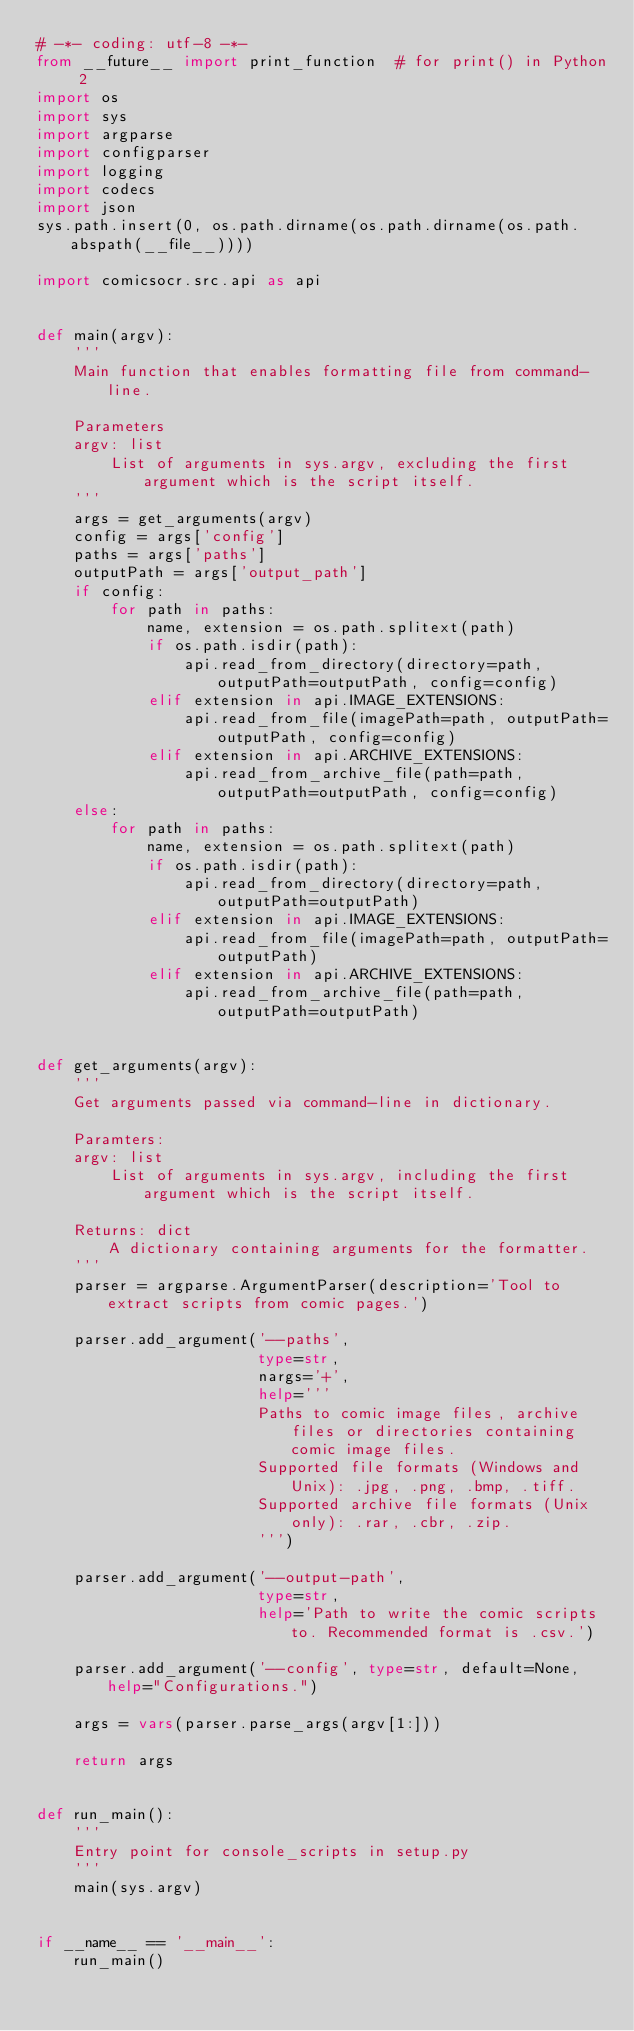<code> <loc_0><loc_0><loc_500><loc_500><_Python_># -*- coding: utf-8 -*-
from __future__ import print_function  # for print() in Python 2
import os
import sys
import argparse
import configparser
import logging
import codecs
import json
sys.path.insert(0, os.path.dirname(os.path.dirname(os.path.abspath(__file__))))

import comicsocr.src.api as api


def main(argv):
    '''
    Main function that enables formatting file from command-line.

    Parameters
    argv: list
        List of arguments in sys.argv, excluding the first argument which is the script itself.
    '''
    args = get_arguments(argv)
    config = args['config']
    paths = args['paths']
    outputPath = args['output_path']
    if config:
        for path in paths:
            name, extension = os.path.splitext(path)
            if os.path.isdir(path):
                api.read_from_directory(directory=path, outputPath=outputPath, config=config)
            elif extension in api.IMAGE_EXTENSIONS:
                api.read_from_file(imagePath=path, outputPath=outputPath, config=config)
            elif extension in api.ARCHIVE_EXTENSIONS:
                api.read_from_archive_file(path=path, outputPath=outputPath, config=config)
    else:
        for path in paths:
            name, extension = os.path.splitext(path)
            if os.path.isdir(path):
                api.read_from_directory(directory=path, outputPath=outputPath)
            elif extension in api.IMAGE_EXTENSIONS:
                api.read_from_file(imagePath=path, outputPath=outputPath)
            elif extension in api.ARCHIVE_EXTENSIONS:
                api.read_from_archive_file(path=path, outputPath=outputPath)


def get_arguments(argv):
    '''
    Get arguments passed via command-line in dictionary.

    Paramters:
    argv: list
        List of arguments in sys.argv, including the first argument which is the script itself.
    
    Returns: dict
        A dictionary containing arguments for the formatter.
    '''
    parser = argparse.ArgumentParser(description='Tool to extract scripts from comic pages.')

    parser.add_argument('--paths',
                        type=str,
                        nargs='+',
                        help='''
                        Paths to comic image files, archive files or directories containing comic image files. 
                        Supported file formats (Windows and Unix): .jpg, .png, .bmp, .tiff.
                        Supported archive file formats (Unix only): .rar, .cbr, .zip.
                        ''')

    parser.add_argument('--output-path',
                        type=str,
                        help='Path to write the comic scripts to. Recommended format is .csv.')

    parser.add_argument('--config', type=str, default=None, help="Configurations.")

    args = vars(parser.parse_args(argv[1:]))

    return args


def run_main():
    '''
    Entry point for console_scripts in setup.py
    '''
    main(sys.argv)


if __name__ == '__main__':
    run_main()
</code> 